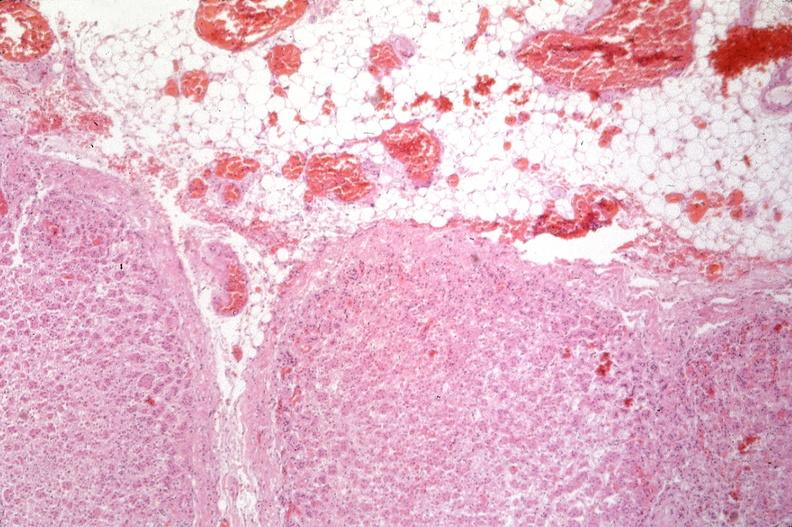why does this image show pancreas, thrombi and hemorrhage?
Answer the question using a single word or phrase. Due to disseminated intravascular coagulation dic 